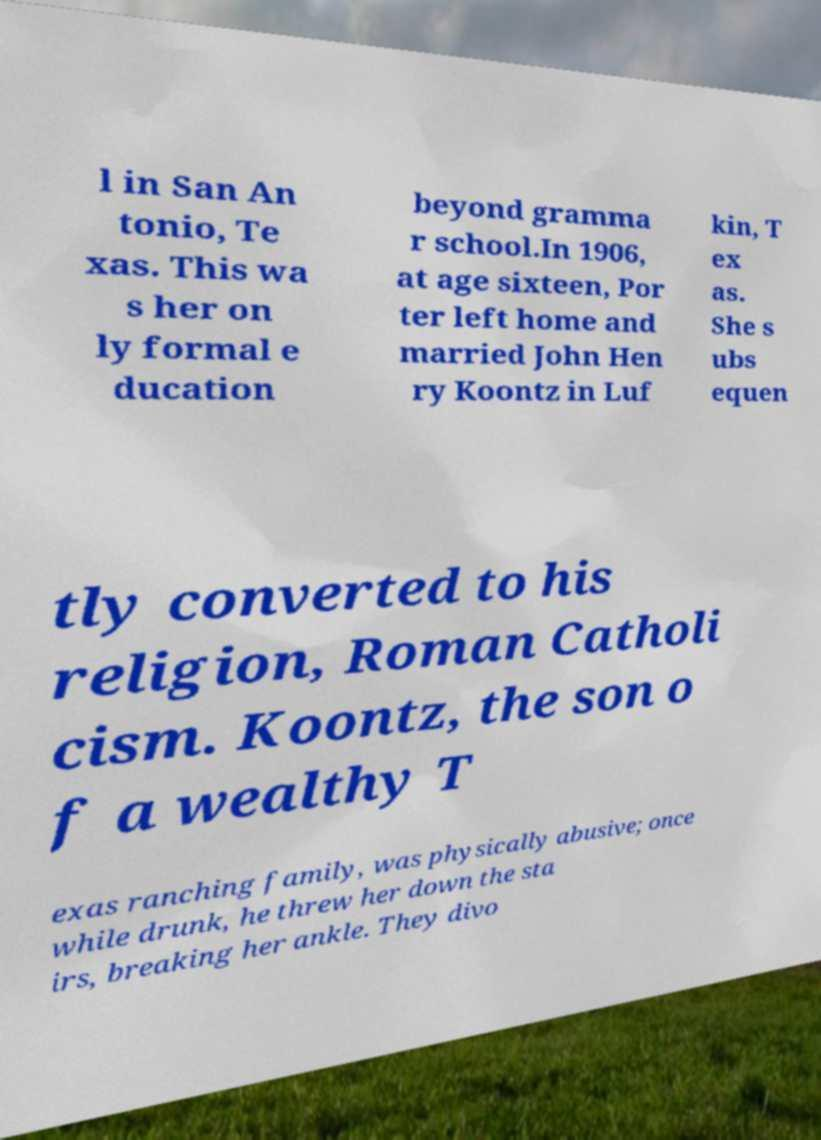Can you accurately transcribe the text from the provided image for me? l in San An tonio, Te xas. This wa s her on ly formal e ducation beyond gramma r school.In 1906, at age sixteen, Por ter left home and married John Hen ry Koontz in Luf kin, T ex as. She s ubs equen tly converted to his religion, Roman Catholi cism. Koontz, the son o f a wealthy T exas ranching family, was physically abusive; once while drunk, he threw her down the sta irs, breaking her ankle. They divo 